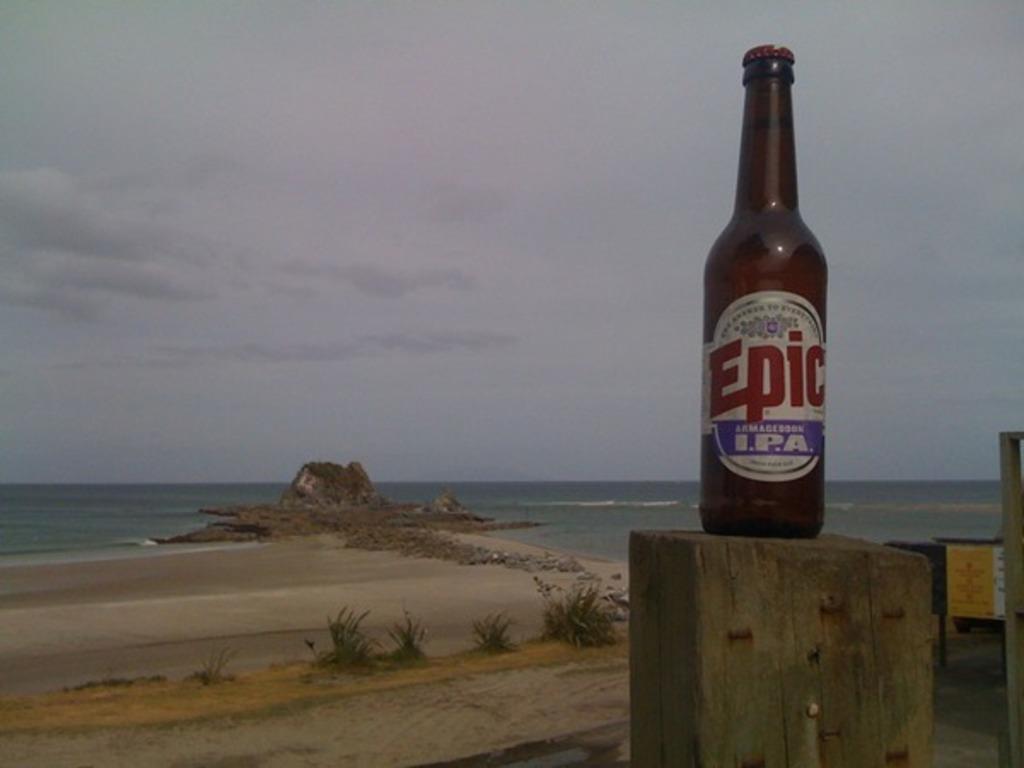Describe this image in one or two sentences. In this picture we can see a bottle on the wood in the background we can see couple of plants and some water. 